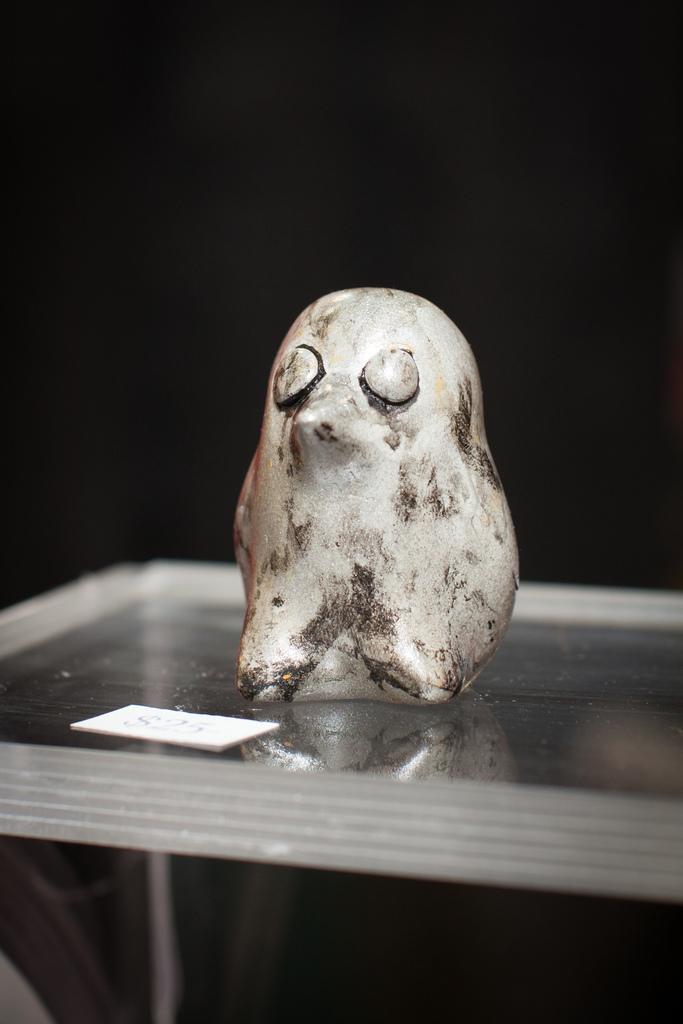How would you summarize this image in a sentence or two? In this image I can see a statue of a bird on a glass table with a label with some text. 